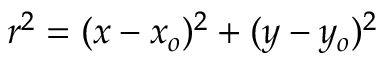Convert formula to latex. <formula><loc_0><loc_0><loc_500><loc_500>r ^ { 2 } = ( x - x _ { o } ) ^ { 2 } + ( y - y _ { o } ) ^ { 2 }</formula> 